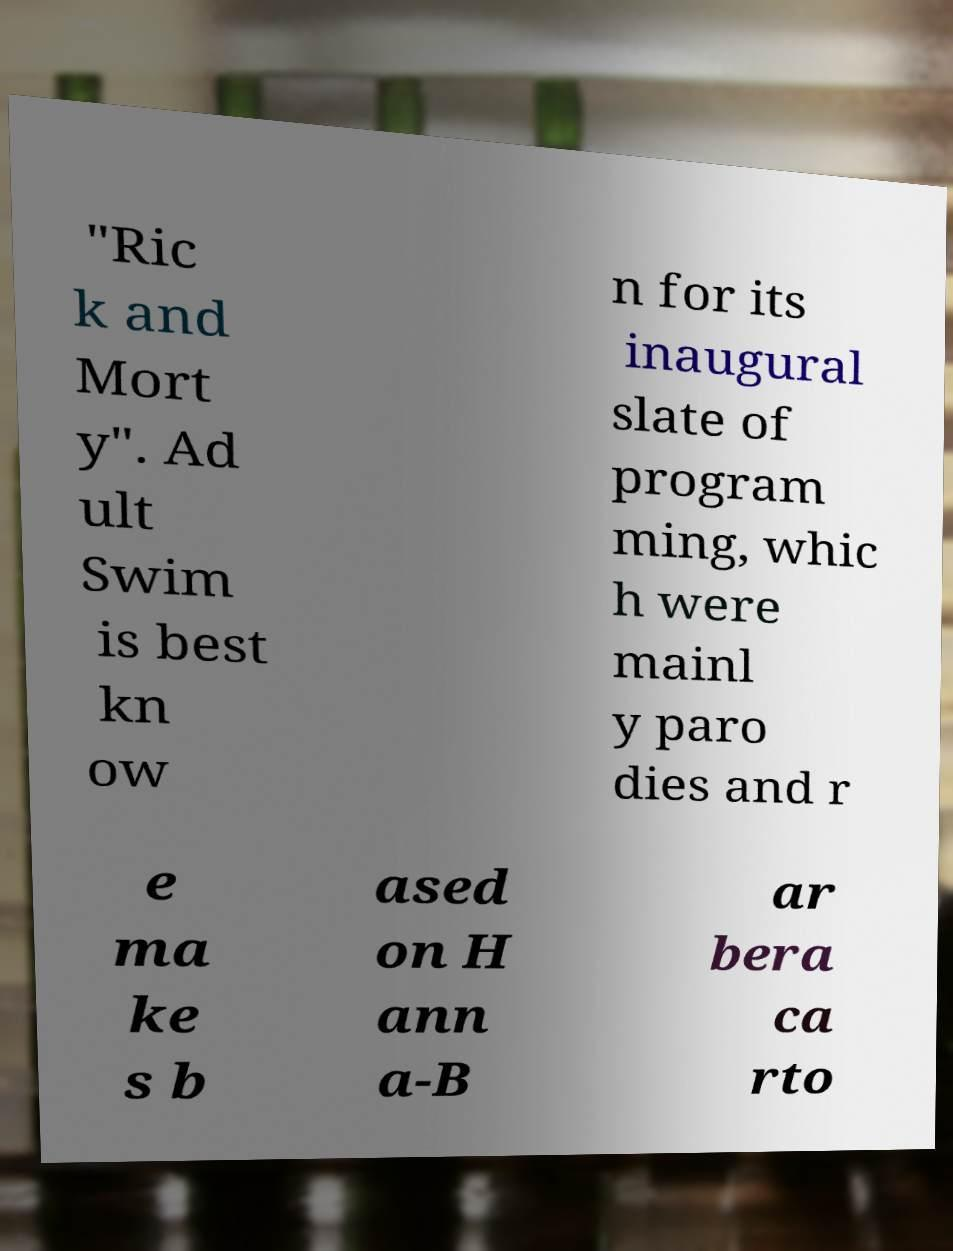Please identify and transcribe the text found in this image. "Ric k and Mort y". Ad ult Swim is best kn ow n for its inaugural slate of program ming, whic h were mainl y paro dies and r e ma ke s b ased on H ann a-B ar bera ca rto 